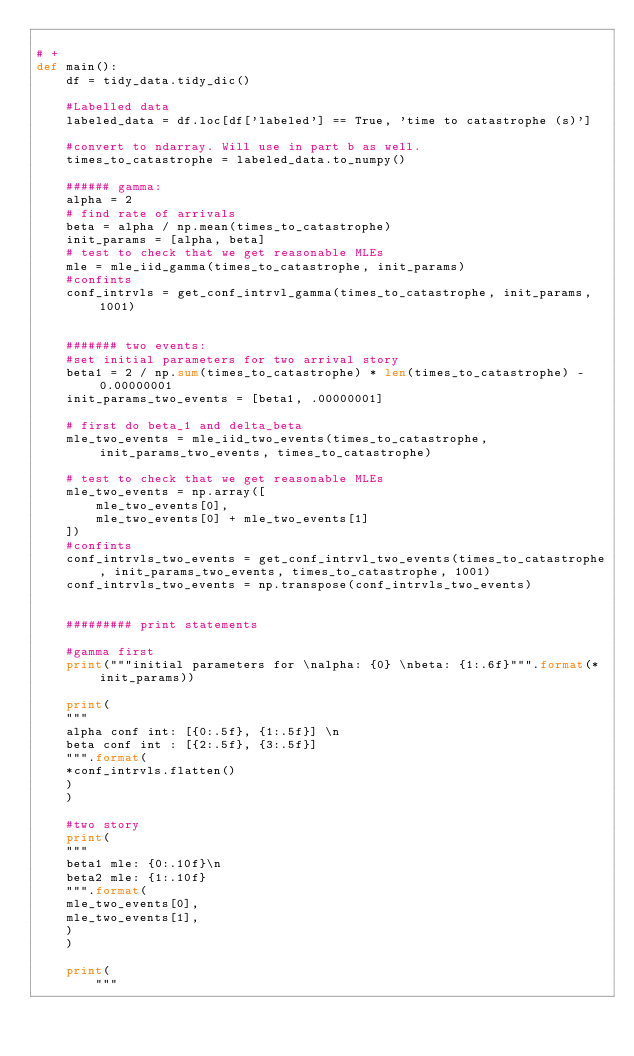Convert code to text. <code><loc_0><loc_0><loc_500><loc_500><_Python_>
# +
def main():
    df = tidy_data.tidy_dic()

    #Labelled data
    labeled_data = df.loc[df['labeled'] == True, 'time to catastrophe (s)']

    #convert to ndarray. Will use in part b as well.
    times_to_catastrophe = labeled_data.to_numpy()
    
    ###### gamma:
    alpha = 2
    # find rate of arrivals
    beta = alpha / np.mean(times_to_catastrophe)
    init_params = [alpha, beta]
    # test to check that we get reasonable MLEs
    mle = mle_iid_gamma(times_to_catastrophe, init_params)
    #confints
    conf_intrvls = get_conf_intrvl_gamma(times_to_catastrophe, init_params, 1001)
    
    
    ####### two events:
    #set initial parameters for two arrival story
    beta1 = 2 / np.sum(times_to_catastrophe) * len(times_to_catastrophe) - 0.00000001
    init_params_two_events = [beta1, .00000001]

    # first do beta_1 and delta_beta
    mle_two_events = mle_iid_two_events(times_to_catastrophe, init_params_two_events, times_to_catastrophe)

    # test to check that we get reasonable MLEs
    mle_two_events = np.array([
        mle_two_events[0],
        mle_two_events[0] + mle_two_events[1]
    ])
    #confints
    conf_intrvls_two_events = get_conf_intrvl_two_events(times_to_catastrophe, init_params_two_events, times_to_catastrophe, 1001)
    conf_intrvls_two_events = np.transpose(conf_intrvls_two_events)
    
    
    ######### print statements
    
    #gamma first
    print("""initial parameters for \nalpha: {0} \nbeta: {1:.6f}""".format(*init_params))
    
    print(
    """
    alpha conf int: [{0:.5f}, {1:.5f}] \n
    beta conf int : [{2:.5f}, {3:.5f}]
    """.format(
    *conf_intrvls.flatten()
    )
    )
    
    #two story
    print(
    """
    beta1 mle: {0:.10f}\n
    beta2 mle: {1:.10f}
    """.format(
    mle_two_events[0],
    mle_two_events[1],
    )
    )
    
    print(
        """</code> 